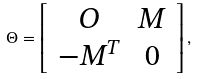Convert formula to latex. <formula><loc_0><loc_0><loc_500><loc_500>\Theta = \left [ \begin{array} { c c } O & M \\ - M ^ { T } & 0 \\ \end{array} \right ] ,</formula> 